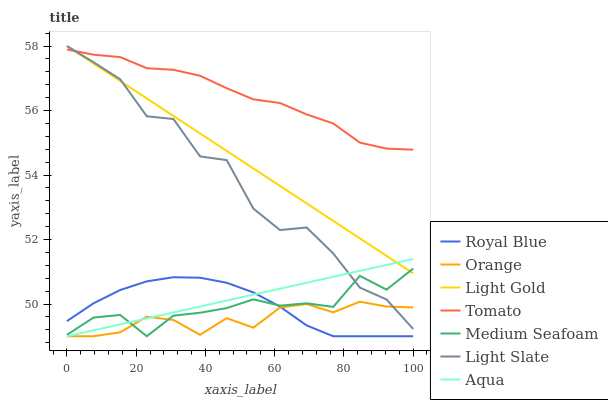Does Orange have the minimum area under the curve?
Answer yes or no. Yes. Does Light Slate have the minimum area under the curve?
Answer yes or no. No. Does Light Slate have the maximum area under the curve?
Answer yes or no. No. Is Light Slate the smoothest?
Answer yes or no. No. Is Aqua the roughest?
Answer yes or no. No. Does Light Slate have the lowest value?
Answer yes or no. No. Does Aqua have the highest value?
Answer yes or no. No. Is Orange less than Tomato?
Answer yes or no. Yes. Is Tomato greater than Aqua?
Answer yes or no. Yes. Does Orange intersect Tomato?
Answer yes or no. No. 